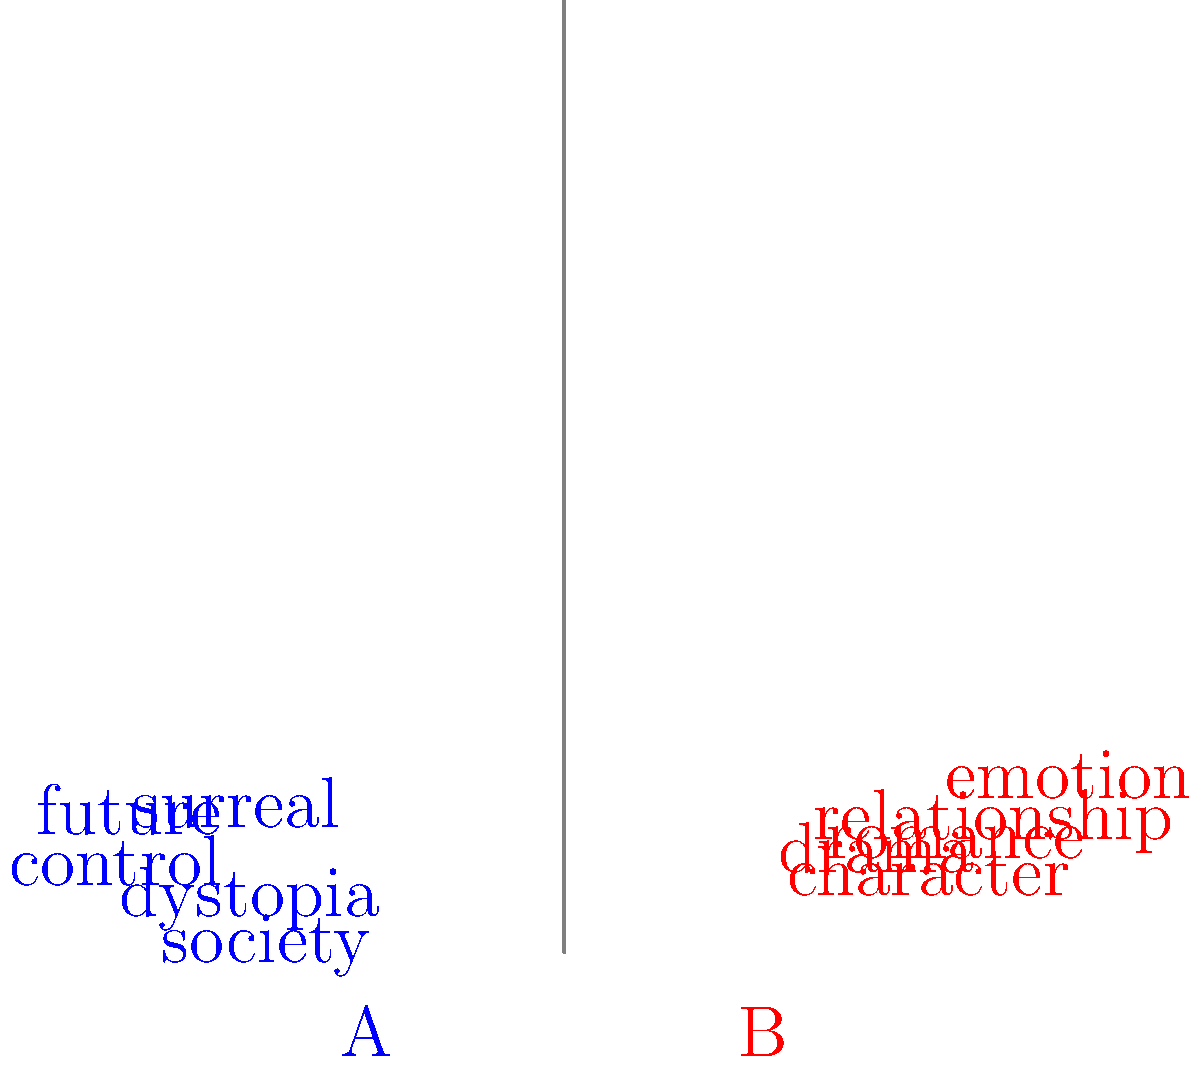As an expert in surreal dystopian novels, analyze the word clouds above. Which one (A or B) is more likely to represent the writing style of your genre, and why? To determine which word cloud best represents the writing style of surreal dystopian novels, we need to analyze the content and themes of each:

1. Word Cloud A (left, blue):
   - Contains words like "dystopia," "surreal," "society," "future," and "control"
   - These words are strongly associated with dystopian and surrealist themes
   - "Dystopia" directly relates to the genre
   - "Surreal" aligns with the surrealist aspect of the writing style
   - "Society," "future," and "control" are common themes in dystopian literature

2. Word Cloud B (right, red):
   - Contains words like "romance," "character," "emotion," "relationship," and "drama"
   - These words are more commonly associated with romantic or character-driven fiction
   - While these elements may be present in dystopian novels, they are not the primary focus of the genre

3. Comparison:
   - Word Cloud A directly addresses the core elements of surreal dystopian fiction
   - Word Cloud B focuses on more general literary elements that are not specific to the dystopian genre

4. Conclusion:
   - Word Cloud A is more likely to represent the writing style of surreal dystopian novels due to its specific vocabulary and themes that align closely with the genre
Answer: A 